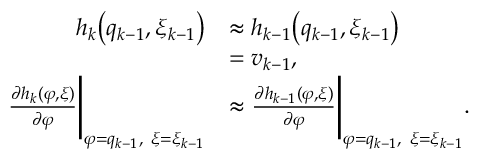<formula> <loc_0><loc_0><loc_500><loc_500>\begin{array} { r l } { h _ { k } \left ( q _ { k - 1 } , \xi _ { k - 1 } \right ) } & { \approx h _ { k - 1 } \left ( q _ { k - 1 } , \xi _ { k - 1 } \right ) } \\ & { = v _ { k - 1 } , } \\ { \frac { \partial h _ { k } ( \varphi , \xi ) } { \partial \varphi } \left | _ { \varphi = q _ { k - 1 } , \xi = \xi _ { k - 1 } } } & { \approx \frac { \partial h _ { k - 1 } ( \varphi , \xi ) } { \partial \varphi } \right | _ { \varphi = q _ { k - 1 } , \xi = \xi _ { k - 1 } } . } \end{array}</formula> 